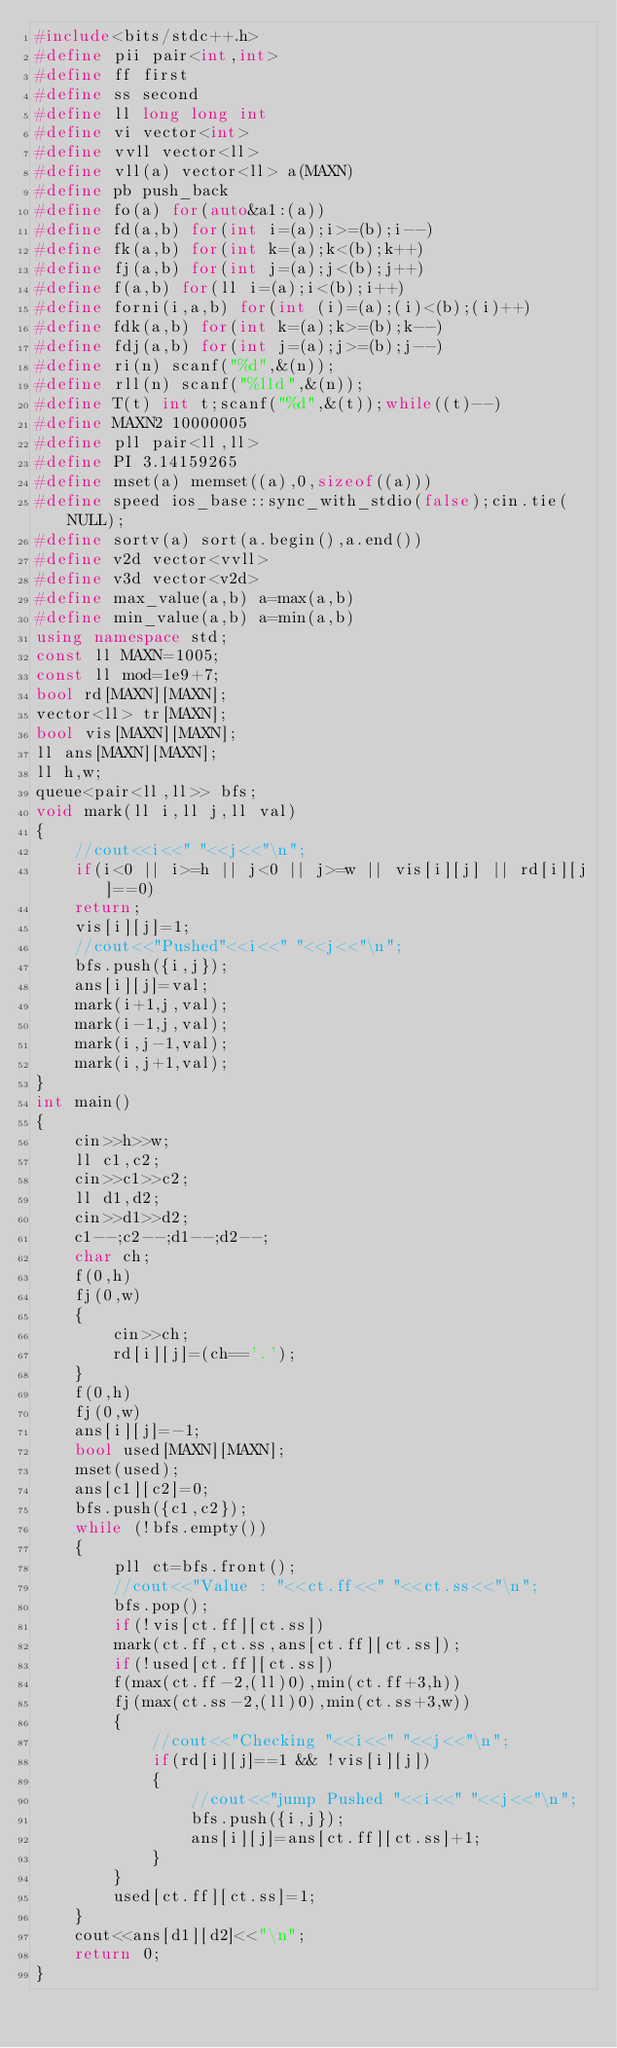<code> <loc_0><loc_0><loc_500><loc_500><_C++_>#include<bits/stdc++.h>
#define pii pair<int,int>
#define ff first
#define ss second
#define ll long long int
#define vi vector<int>
#define vvll vector<ll>
#define vll(a) vector<ll> a(MAXN)
#define pb push_back
#define fo(a) for(auto&a1:(a))
#define fd(a,b) for(int i=(a);i>=(b);i--)
#define fk(a,b) for(int k=(a);k<(b);k++)
#define fj(a,b) for(int j=(a);j<(b);j++)
#define f(a,b) for(ll i=(a);i<(b);i++)
#define forni(i,a,b) for(int (i)=(a);(i)<(b);(i)++)
#define fdk(a,b) for(int k=(a);k>=(b);k--)
#define fdj(a,b) for(int j=(a);j>=(b);j--)
#define ri(n) scanf("%d",&(n));
#define rll(n) scanf("%lld",&(n));
#define T(t) int t;scanf("%d",&(t));while((t)--)
#define MAXN2 10000005
#define pll pair<ll,ll>
#define PI 3.14159265
#define mset(a) memset((a),0,sizeof((a)))
#define speed ios_base::sync_with_stdio(false);cin.tie(NULL);
#define sortv(a) sort(a.begin(),a.end())
#define v2d vector<vvll>
#define v3d vector<v2d>
#define max_value(a,b) a=max(a,b)
#define min_value(a,b) a=min(a,b)
using namespace std;
const ll MAXN=1005;
const ll mod=1e9+7;
bool rd[MAXN][MAXN];
vector<ll> tr[MAXN];
bool vis[MAXN][MAXN];
ll ans[MAXN][MAXN];
ll h,w;
queue<pair<ll,ll>> bfs;
void mark(ll i,ll j,ll val)
{
	//cout<<i<<" "<<j<<"\n";
	if(i<0 || i>=h || j<0 || j>=w || vis[i][j] || rd[i][j]==0)
	return;
	vis[i][j]=1;
	//cout<<"Pushed"<<i<<" "<<j<<"\n";
	bfs.push({i,j});
	ans[i][j]=val;
	mark(i+1,j,val);
	mark(i-1,j,val);
	mark(i,j-1,val);
	mark(i,j+1,val);
}
int main()
{
	cin>>h>>w;
	ll c1,c2;
	cin>>c1>>c2;
	ll d1,d2;
	cin>>d1>>d2;
	c1--;c2--;d1--;d2--;
	char ch;
	f(0,h)
	fj(0,w)
	{
		cin>>ch;
		rd[i][j]=(ch=='.');
	}
	f(0,h)
	fj(0,w)
	ans[i][j]=-1;
	bool used[MAXN][MAXN];
	mset(used);
	ans[c1][c2]=0;
	bfs.push({c1,c2});
	while (!bfs.empty())
	{
		pll ct=bfs.front();
		//cout<<"Value : "<<ct.ff<<" "<<ct.ss<<"\n";
		bfs.pop();
		if(!vis[ct.ff][ct.ss])
		mark(ct.ff,ct.ss,ans[ct.ff][ct.ss]);
		if(!used[ct.ff][ct.ss])
		f(max(ct.ff-2,(ll)0),min(ct.ff+3,h))
		fj(max(ct.ss-2,(ll)0),min(ct.ss+3,w))
		{
			//cout<<"Checking "<<i<<" "<<j<<"\n";
			if(rd[i][j]==1 && !vis[i][j])
			{
				//cout<<"jump Pushed "<<i<<" "<<j<<"\n";
				bfs.push({i,j});
				ans[i][j]=ans[ct.ff][ct.ss]+1;
			}
		}
		used[ct.ff][ct.ss]=1;
	}
	cout<<ans[d1][d2]<<"\n";
    return 0;
}
</code> 